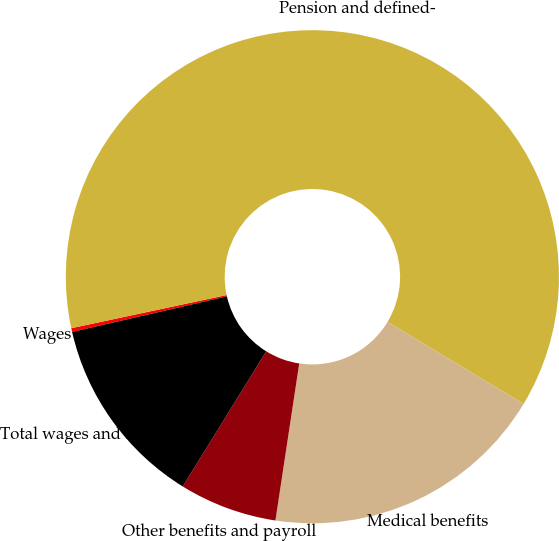<chart> <loc_0><loc_0><loc_500><loc_500><pie_chart><fcel>Wages<fcel>Pension and defined-<fcel>Medical benefits<fcel>Other benefits and payroll<fcel>Total wages and benefits<nl><fcel>0.25%<fcel>61.97%<fcel>18.77%<fcel>6.42%<fcel>12.59%<nl></chart> 